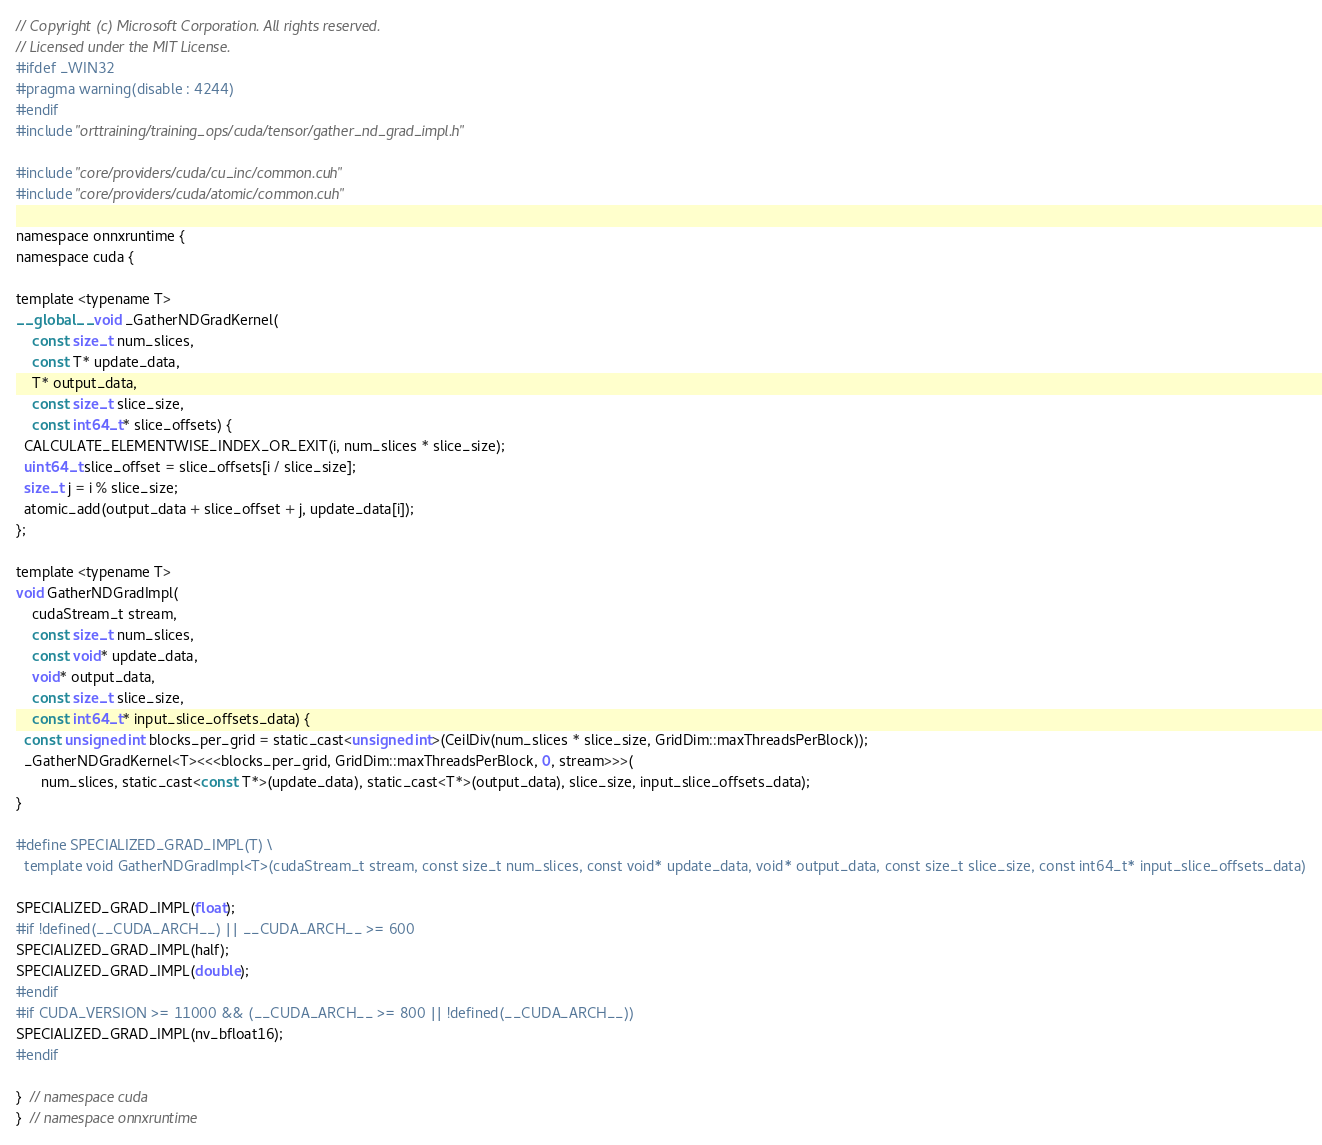<code> <loc_0><loc_0><loc_500><loc_500><_Cuda_>// Copyright (c) Microsoft Corporation. All rights reserved.
// Licensed under the MIT License.
#ifdef _WIN32
#pragma warning(disable : 4244)
#endif
#include "orttraining/training_ops/cuda/tensor/gather_nd_grad_impl.h"

#include "core/providers/cuda/cu_inc/common.cuh"
#include "core/providers/cuda/atomic/common.cuh"

namespace onnxruntime {
namespace cuda {

template <typename T>
__global__ void _GatherNDGradKernel(
    const size_t num_slices,
    const T* update_data,
    T* output_data,
    const size_t slice_size,
    const int64_t* slice_offsets) {
  CALCULATE_ELEMENTWISE_INDEX_OR_EXIT(i, num_slices * slice_size);
  uint64_t slice_offset = slice_offsets[i / slice_size];
  size_t j = i % slice_size;
  atomic_add(output_data + slice_offset + j, update_data[i]);
};

template <typename T>
void GatherNDGradImpl(
    cudaStream_t stream,
    const size_t num_slices,
    const void* update_data,
    void* output_data,
    const size_t slice_size,
    const int64_t* input_slice_offsets_data) {
  const unsigned int blocks_per_grid = static_cast<unsigned int>(CeilDiv(num_slices * slice_size, GridDim::maxThreadsPerBlock));
  _GatherNDGradKernel<T><<<blocks_per_grid, GridDim::maxThreadsPerBlock, 0, stream>>>(
      num_slices, static_cast<const T*>(update_data), static_cast<T*>(output_data), slice_size, input_slice_offsets_data);
}

#define SPECIALIZED_GRAD_IMPL(T) \
  template void GatherNDGradImpl<T>(cudaStream_t stream, const size_t num_slices, const void* update_data, void* output_data, const size_t slice_size, const int64_t* input_slice_offsets_data)

SPECIALIZED_GRAD_IMPL(float);
#if !defined(__CUDA_ARCH__) || __CUDA_ARCH__ >= 600
SPECIALIZED_GRAD_IMPL(half);
SPECIALIZED_GRAD_IMPL(double);
#endif
#if CUDA_VERSION >= 11000 && (__CUDA_ARCH__ >= 800 || !defined(__CUDA_ARCH__))
SPECIALIZED_GRAD_IMPL(nv_bfloat16);
#endif

}  // namespace cuda
}  // namespace onnxruntime
</code> 